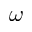<formula> <loc_0><loc_0><loc_500><loc_500>\boldsymbol \omega</formula> 